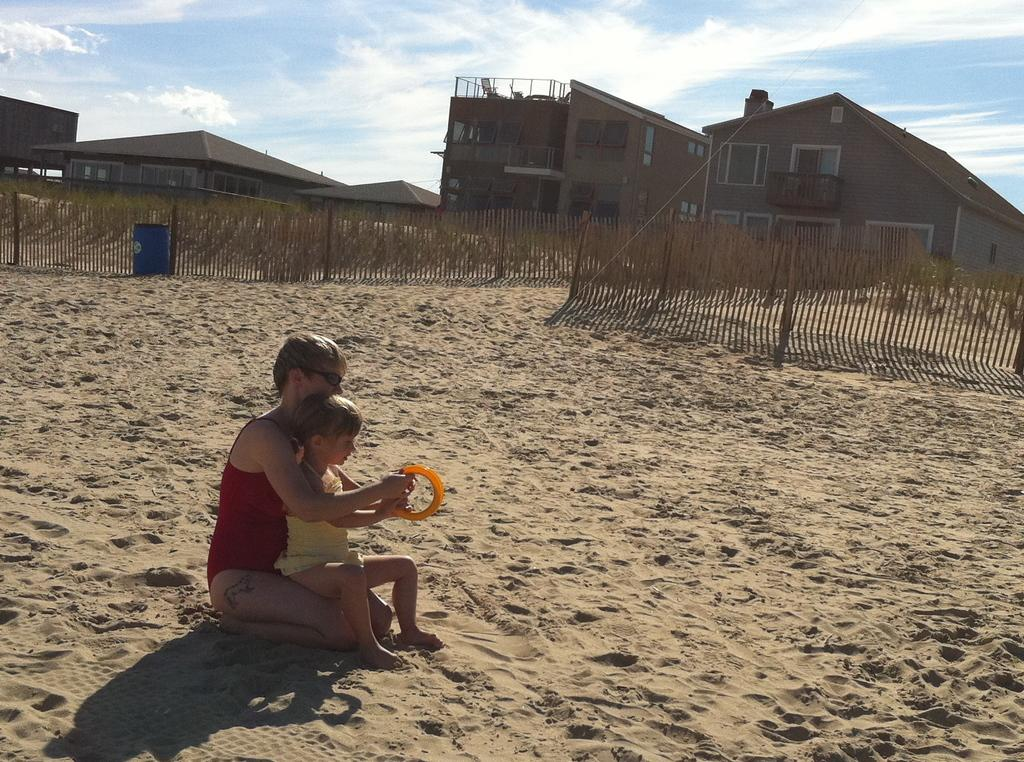What is the girl doing in the image? The girl is sitting on a woman in the image. What can be seen in the background of the image? The sky is visible in the background of the image, and there are clouds in the sky. What type of surface is visible in the image? There is sand in the image. What other objects or structures can be seen in the image? There is a fence, plants, houses, and a woman in the image. What type of stem can be seen growing from the key in the image? There is no stem or key present in the image. 